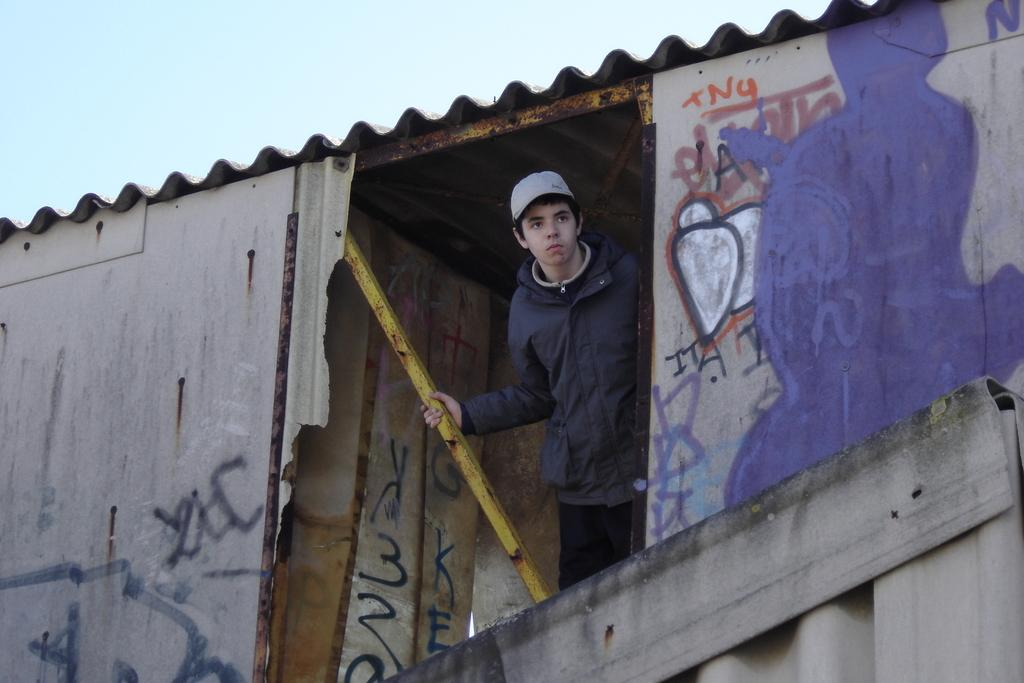Who is present in the image? There is a boy in the image. What is the boy doing in the image? The boy is standing in a shake. What is the structure of the shake? The shake has a tin roof. What is the boy wearing in the image? The boy is wearing a coat and a cap. What can be seen on the walls in the image? There is spray paint on the walls. What is visible at the top of the image? The sky is visible at the top of the image. What type of wire is used to hang the cherry in the image? There is no wire or cherry present in the image. 